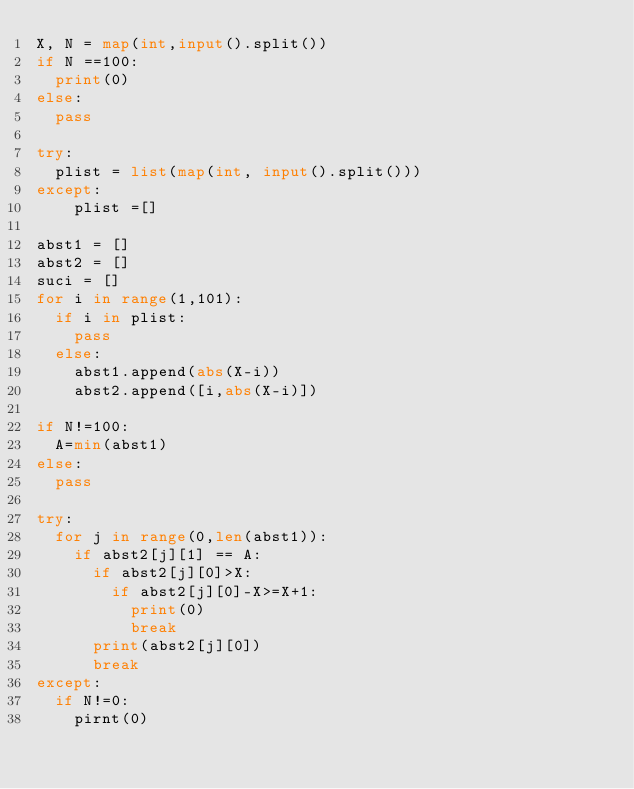<code> <loc_0><loc_0><loc_500><loc_500><_Python_>X, N = map(int,input().split())
if N ==100:
  print(0)
else:
  pass

try:
  plist = list(map(int, input().split()))
except:
	plist =[]

abst1 = []
abst2 = []
suci = []
for i in range(1,101):
  if i in plist:
    pass
  else:
    abst1.append(abs(X-i))
    abst2.append([i,abs(X-i)])

if N!=100:
  A=min(abst1)
else:
  pass
  
try:
  for j in range(0,len(abst1)):
    if abst2[j][1] == A:
      if abst2[j][0]>X:
        if abst2[j][0]-X>=X+1:
          print(0)
          break
      print(abst2[j][0])
      break
except:
  if N!=0:
    pirnt(0)</code> 